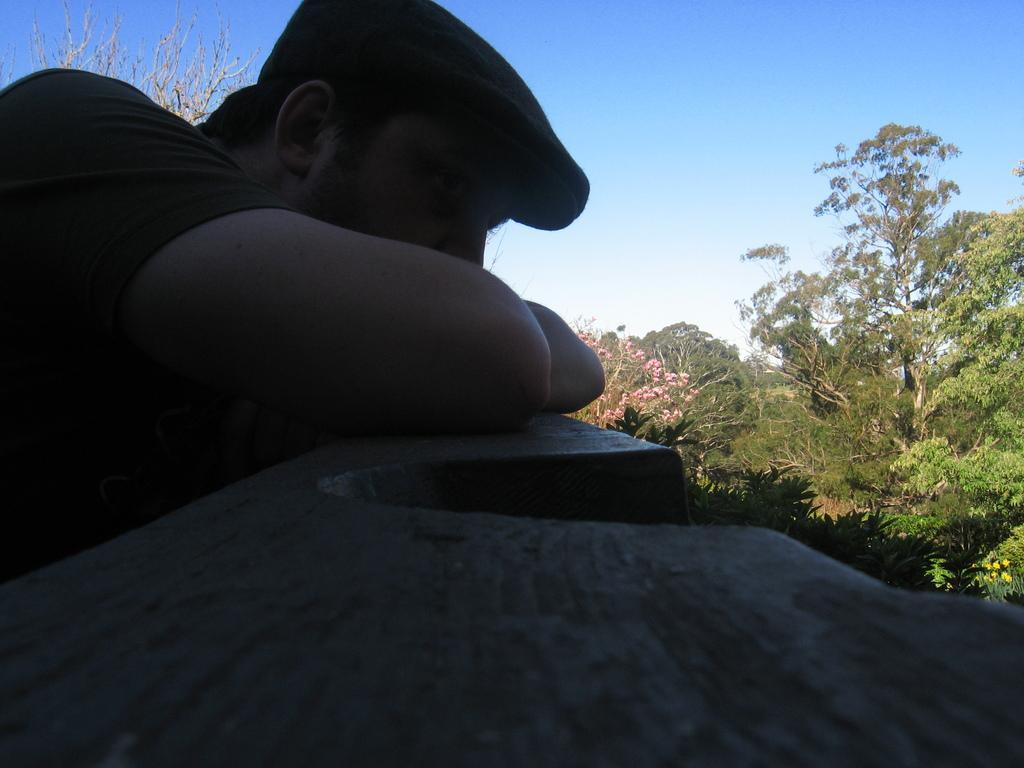Could you give a brief overview of what you see in this image? In this image, there is a man standing and he is wearing a hat, at the right side there are some green color trees, at the top there is a blue color sky. 